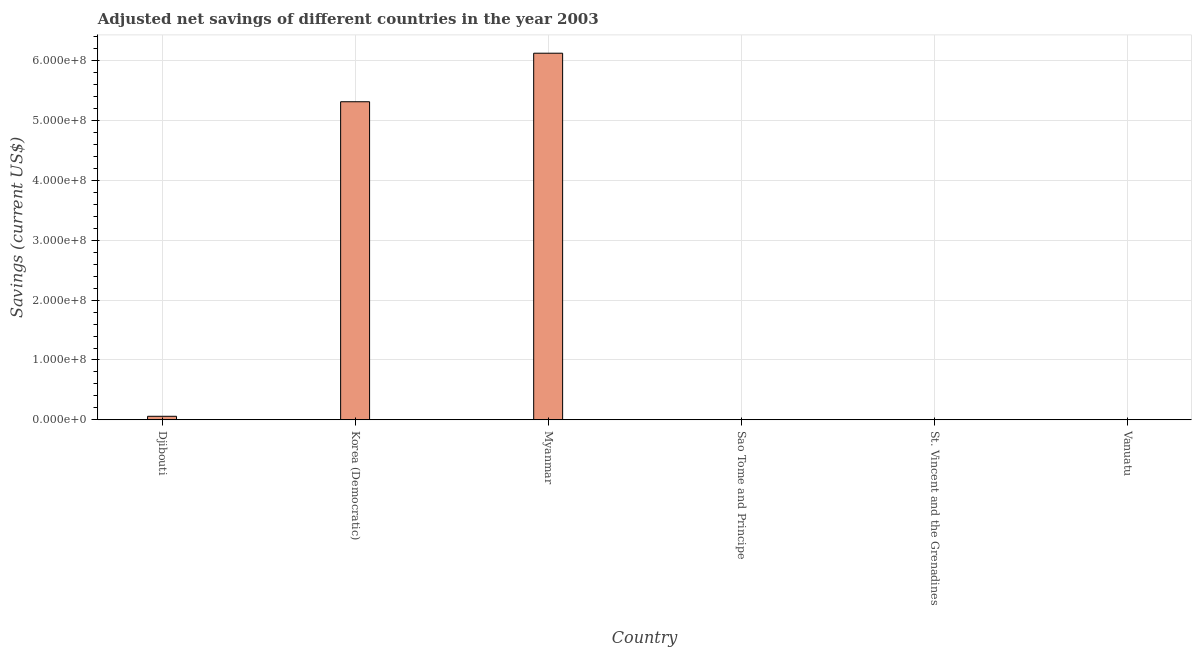Does the graph contain grids?
Offer a terse response. Yes. What is the title of the graph?
Make the answer very short. Adjusted net savings of different countries in the year 2003. What is the label or title of the X-axis?
Provide a succinct answer. Country. What is the label or title of the Y-axis?
Your answer should be compact. Savings (current US$). What is the adjusted net savings in Vanuatu?
Your response must be concise. 2.46e+05. Across all countries, what is the maximum adjusted net savings?
Provide a succinct answer. 6.13e+08. Across all countries, what is the minimum adjusted net savings?
Keep it short and to the point. 1.27e+04. In which country was the adjusted net savings maximum?
Offer a very short reply. Myanmar. In which country was the adjusted net savings minimum?
Make the answer very short. Sao Tome and Principe. What is the sum of the adjusted net savings?
Your answer should be compact. 1.15e+09. What is the difference between the adjusted net savings in Korea (Democratic) and Myanmar?
Your answer should be very brief. -8.11e+07. What is the average adjusted net savings per country?
Give a very brief answer. 1.92e+08. What is the median adjusted net savings?
Ensure brevity in your answer.  3.06e+06. What is the ratio of the adjusted net savings in Djibouti to that in Korea (Democratic)?
Offer a very short reply. 0.01. Is the adjusted net savings in Sao Tome and Principe less than that in Vanuatu?
Your answer should be very brief. Yes. Is the difference between the adjusted net savings in Djibouti and St. Vincent and the Grenadines greater than the difference between any two countries?
Ensure brevity in your answer.  No. What is the difference between the highest and the second highest adjusted net savings?
Offer a very short reply. 8.11e+07. Is the sum of the adjusted net savings in Djibouti and St. Vincent and the Grenadines greater than the maximum adjusted net savings across all countries?
Keep it short and to the point. No. What is the difference between the highest and the lowest adjusted net savings?
Your answer should be compact. 6.13e+08. How many countries are there in the graph?
Keep it short and to the point. 6. What is the difference between two consecutive major ticks on the Y-axis?
Keep it short and to the point. 1.00e+08. What is the Savings (current US$) in Djibouti?
Provide a succinct answer. 5.88e+06. What is the Savings (current US$) in Korea (Democratic)?
Make the answer very short. 5.32e+08. What is the Savings (current US$) in Myanmar?
Give a very brief answer. 6.13e+08. What is the Savings (current US$) of Sao Tome and Principe?
Make the answer very short. 1.27e+04. What is the Savings (current US$) in St. Vincent and the Grenadines?
Ensure brevity in your answer.  1.18e+05. What is the Savings (current US$) of Vanuatu?
Ensure brevity in your answer.  2.46e+05. What is the difference between the Savings (current US$) in Djibouti and Korea (Democratic)?
Your response must be concise. -5.26e+08. What is the difference between the Savings (current US$) in Djibouti and Myanmar?
Provide a short and direct response. -6.07e+08. What is the difference between the Savings (current US$) in Djibouti and Sao Tome and Principe?
Offer a terse response. 5.87e+06. What is the difference between the Savings (current US$) in Djibouti and St. Vincent and the Grenadines?
Provide a succinct answer. 5.76e+06. What is the difference between the Savings (current US$) in Djibouti and Vanuatu?
Ensure brevity in your answer.  5.63e+06. What is the difference between the Savings (current US$) in Korea (Democratic) and Myanmar?
Ensure brevity in your answer.  -8.11e+07. What is the difference between the Savings (current US$) in Korea (Democratic) and Sao Tome and Principe?
Provide a succinct answer. 5.32e+08. What is the difference between the Savings (current US$) in Korea (Democratic) and St. Vincent and the Grenadines?
Offer a very short reply. 5.32e+08. What is the difference between the Savings (current US$) in Korea (Democratic) and Vanuatu?
Offer a very short reply. 5.31e+08. What is the difference between the Savings (current US$) in Myanmar and Sao Tome and Principe?
Make the answer very short. 6.13e+08. What is the difference between the Savings (current US$) in Myanmar and St. Vincent and the Grenadines?
Your answer should be very brief. 6.13e+08. What is the difference between the Savings (current US$) in Myanmar and Vanuatu?
Your response must be concise. 6.12e+08. What is the difference between the Savings (current US$) in Sao Tome and Principe and St. Vincent and the Grenadines?
Give a very brief answer. -1.05e+05. What is the difference between the Savings (current US$) in Sao Tome and Principe and Vanuatu?
Ensure brevity in your answer.  -2.33e+05. What is the difference between the Savings (current US$) in St. Vincent and the Grenadines and Vanuatu?
Offer a very short reply. -1.28e+05. What is the ratio of the Savings (current US$) in Djibouti to that in Korea (Democratic)?
Provide a short and direct response. 0.01. What is the ratio of the Savings (current US$) in Djibouti to that in Myanmar?
Provide a short and direct response. 0.01. What is the ratio of the Savings (current US$) in Djibouti to that in Sao Tome and Principe?
Your answer should be compact. 462. What is the ratio of the Savings (current US$) in Djibouti to that in St. Vincent and the Grenadines?
Your answer should be very brief. 49.9. What is the ratio of the Savings (current US$) in Djibouti to that in Vanuatu?
Ensure brevity in your answer.  23.91. What is the ratio of the Savings (current US$) in Korea (Democratic) to that in Myanmar?
Keep it short and to the point. 0.87. What is the ratio of the Savings (current US$) in Korea (Democratic) to that in Sao Tome and Principe?
Provide a short and direct response. 4.18e+04. What is the ratio of the Savings (current US$) in Korea (Democratic) to that in St. Vincent and the Grenadines?
Provide a short and direct response. 4512.8. What is the ratio of the Savings (current US$) in Korea (Democratic) to that in Vanuatu?
Provide a succinct answer. 2162.07. What is the ratio of the Savings (current US$) in Myanmar to that in Sao Tome and Principe?
Your answer should be very brief. 4.82e+04. What is the ratio of the Savings (current US$) in Myanmar to that in St. Vincent and the Grenadines?
Offer a very short reply. 5201.4. What is the ratio of the Savings (current US$) in Myanmar to that in Vanuatu?
Keep it short and to the point. 2491.98. What is the ratio of the Savings (current US$) in Sao Tome and Principe to that in St. Vincent and the Grenadines?
Offer a terse response. 0.11. What is the ratio of the Savings (current US$) in Sao Tome and Principe to that in Vanuatu?
Provide a short and direct response. 0.05. What is the ratio of the Savings (current US$) in St. Vincent and the Grenadines to that in Vanuatu?
Ensure brevity in your answer.  0.48. 